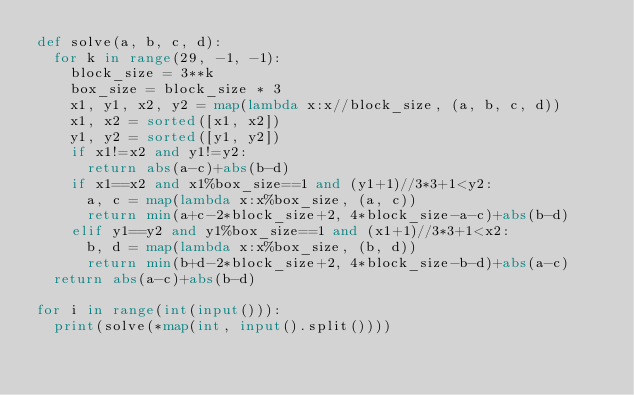<code> <loc_0><loc_0><loc_500><loc_500><_Python_>def solve(a, b, c, d):
  for k in range(29, -1, -1):
    block_size = 3**k
    box_size = block_size * 3
    x1, y1, x2, y2 = map(lambda x:x//block_size, (a, b, c, d))
    x1, x2 = sorted([x1, x2])
    y1, y2 = sorted([y1, y2])
    if x1!=x2 and y1!=y2:
      return abs(a-c)+abs(b-d)
    if x1==x2 and x1%box_size==1 and (y1+1)//3*3+1<y2:
      a, c = map(lambda x:x%box_size, (a, c))
      return min(a+c-2*block_size+2, 4*block_size-a-c)+abs(b-d)
    elif y1==y2 and y1%box_size==1 and (x1+1)//3*3+1<x2:
      b, d = map(lambda x:x%box_size, (b, d))
      return min(b+d-2*block_size+2, 4*block_size-b-d)+abs(a-c)
  return abs(a-c)+abs(b-d)

for i in range(int(input())):
  print(solve(*map(int, input().split())))
</code> 